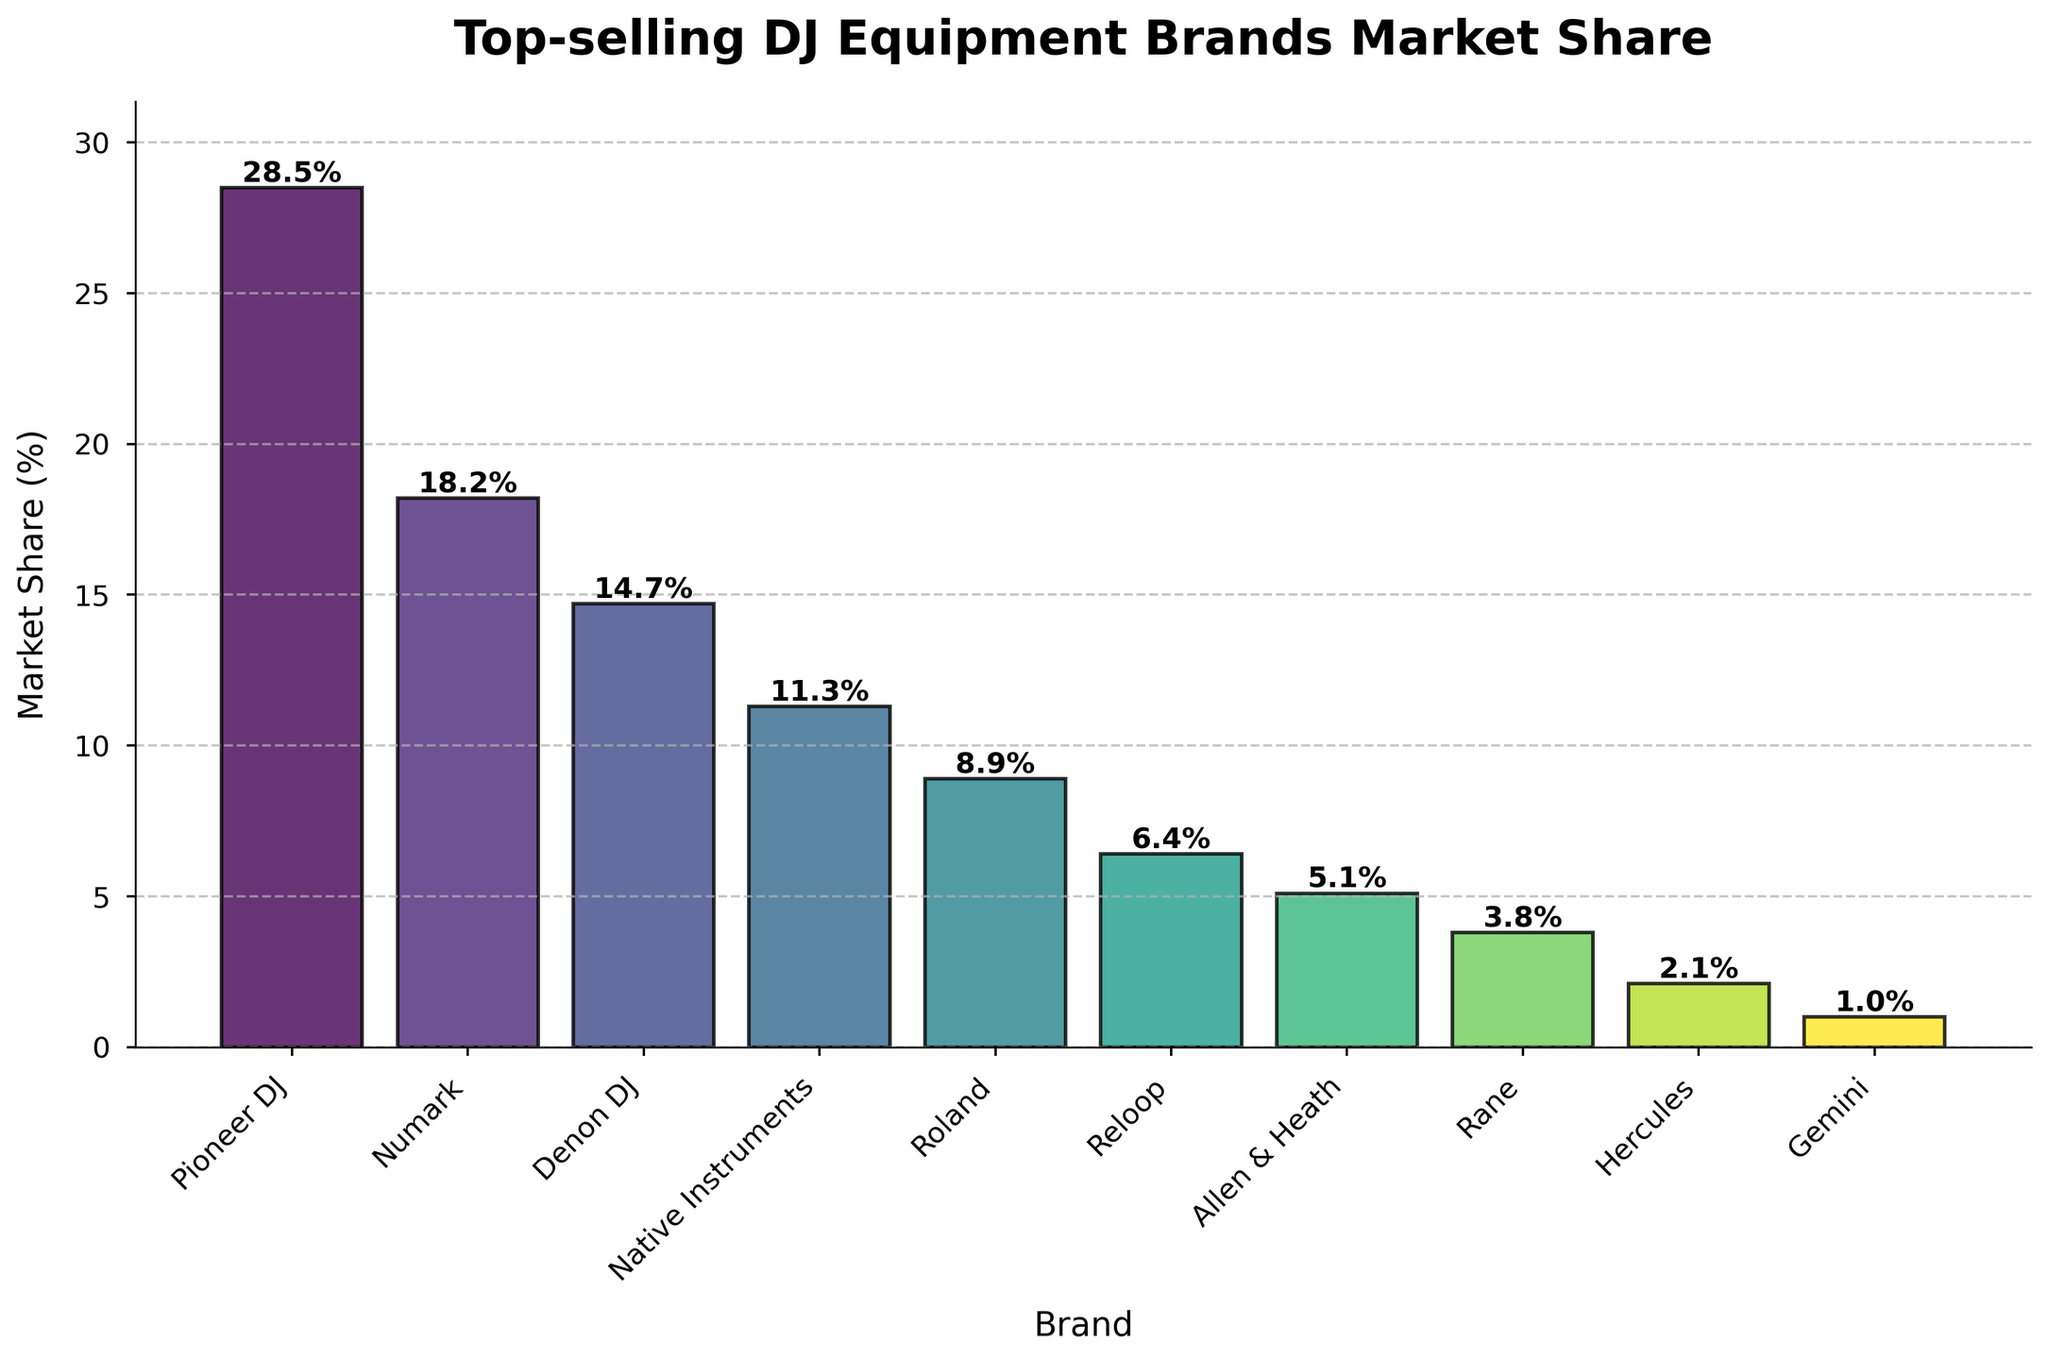What are the top three DJ equipment brands in terms of market share? The top three brands are the ones with the highest market share percentages. Looking at the bar chart, Pioneer DJ has the highest, followed by Numark, and then Denon DJ.
Answer: Pioneer DJ, Numark, Denon DJ Which DJ equipment brand has a market share closest to 10%? To find the brand with a market share closest to 10%, we need to identify which bar is nearest to the 10% mark on the y-axis. Native Instruments has a market share of 11.3%, which is closest to 10%.
Answer: Native Instruments How much higher is Pioneer DJ's market share compared to Roland's? Pioneer DJ's market share is 28.5%, and Roland's is 8.9%. Subtracting Roland's share from Pioneer DJ's gives 28.5% - 8.9% = 19.6%.
Answer: 19.6% What is the combined market share of Denon DJ, Native Instruments, and Roland? Adding the market shares of Denon DJ, Native Instruments, and Roland: 14.7% + 11.3% + 8.9% = 34.9%.
Answer: 34.9% Which brand has the smallest market share, and what is its value? The smallest market share can be identified by the shortest bar. Gemini has the smallest market share, which is 1.0%.
Answer: Gemini, 1.0% Is the market share of Numark greater than or equal to the combined market share of Reloop and Allen & Heath? Numark's market share is 18.2%. Reloop's is 6.4%, and Allen & Heath's is 5.1%. The combined market share of Reloop and Allen & Heath is 6.4% + 5.1% = 11.5%. Since 18.2% is greater than 11.5%, Numark's share is indeed greater.
Answer: Yes How many brands have a market share less than 10%? Counting the bars corresponding to brands with a market share less than 10%: Reloop, Allen & Heath, Rane, Hercules, and Gemini. This gives a total of 5 brands.
Answer: 5 brands Which two brands combined have a market share just above 20%? We seek two brands whose market shares add up to slightly more than 20%. Checking combinations, Numark (18.2%) and Gemini (1.0%) give 18.2% + 1.0% = 19.2%, which is close but not above 20%. Numark and Allen & Heath combined give 18.2% + 5.1% = 23.3%, which fits.
Answer: Numark, Allen & Heath What is the average market share of all the brands? Summing all the market shares: 28.5 + 18.2 + 14.7 + 11.3 + 8.9 + 6.4 + 5.1 + 3.8 + 2.1 + 1.0 = 100%. Dividing by the 10 brands gives an average of 100%/10 = 10%.
Answer: 10% What visual features distinguish the top brand from the others in the chart? The top brand, Pioneer DJ, is distinguished by having the tallest bar, which indicates the highest market share. Additionally, the bar's height relative to others and its color, due to the color gradient, make it visually prominent.
Answer: Tallest bar, most prominent 